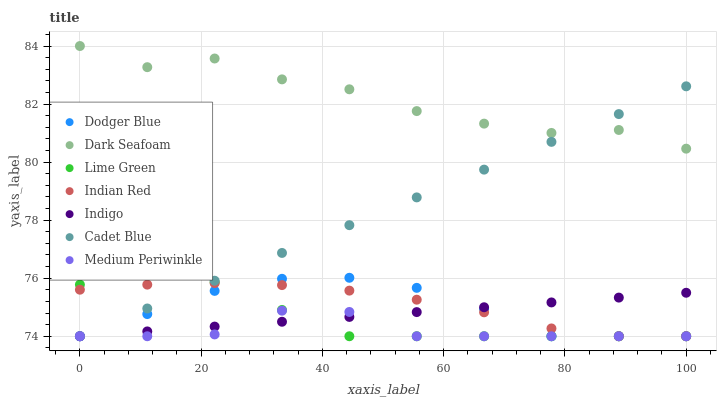Does Medium Periwinkle have the minimum area under the curve?
Answer yes or no. Yes. Does Dark Seafoam have the maximum area under the curve?
Answer yes or no. Yes. Does Indigo have the minimum area under the curve?
Answer yes or no. No. Does Indigo have the maximum area under the curve?
Answer yes or no. No. Is Cadet Blue the smoothest?
Answer yes or no. Yes. Is Dark Seafoam the roughest?
Answer yes or no. Yes. Is Indigo the smoothest?
Answer yes or no. No. Is Indigo the roughest?
Answer yes or no. No. Does Cadet Blue have the lowest value?
Answer yes or no. Yes. Does Dark Seafoam have the lowest value?
Answer yes or no. No. Does Dark Seafoam have the highest value?
Answer yes or no. Yes. Does Indigo have the highest value?
Answer yes or no. No. Is Lime Green less than Dark Seafoam?
Answer yes or no. Yes. Is Dark Seafoam greater than Medium Periwinkle?
Answer yes or no. Yes. Does Medium Periwinkle intersect Lime Green?
Answer yes or no. Yes. Is Medium Periwinkle less than Lime Green?
Answer yes or no. No. Is Medium Periwinkle greater than Lime Green?
Answer yes or no. No. Does Lime Green intersect Dark Seafoam?
Answer yes or no. No. 